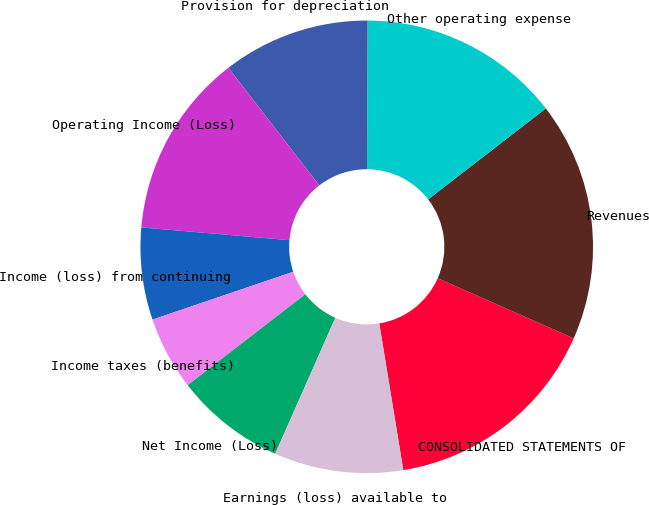Convert chart to OTSL. <chart><loc_0><loc_0><loc_500><loc_500><pie_chart><fcel>CONSOLIDATED STATEMENTS OF<fcel>Revenues<fcel>Other operating expense<fcel>Provision for depreciation<fcel>Operating Income (Loss)<fcel>Income (loss) from continuing<fcel>Income taxes (benefits)<fcel>Net Income (Loss)<fcel>Earnings (loss) available to<nl><fcel>15.79%<fcel>17.1%<fcel>14.47%<fcel>10.53%<fcel>13.16%<fcel>6.58%<fcel>5.26%<fcel>7.9%<fcel>9.21%<nl></chart> 